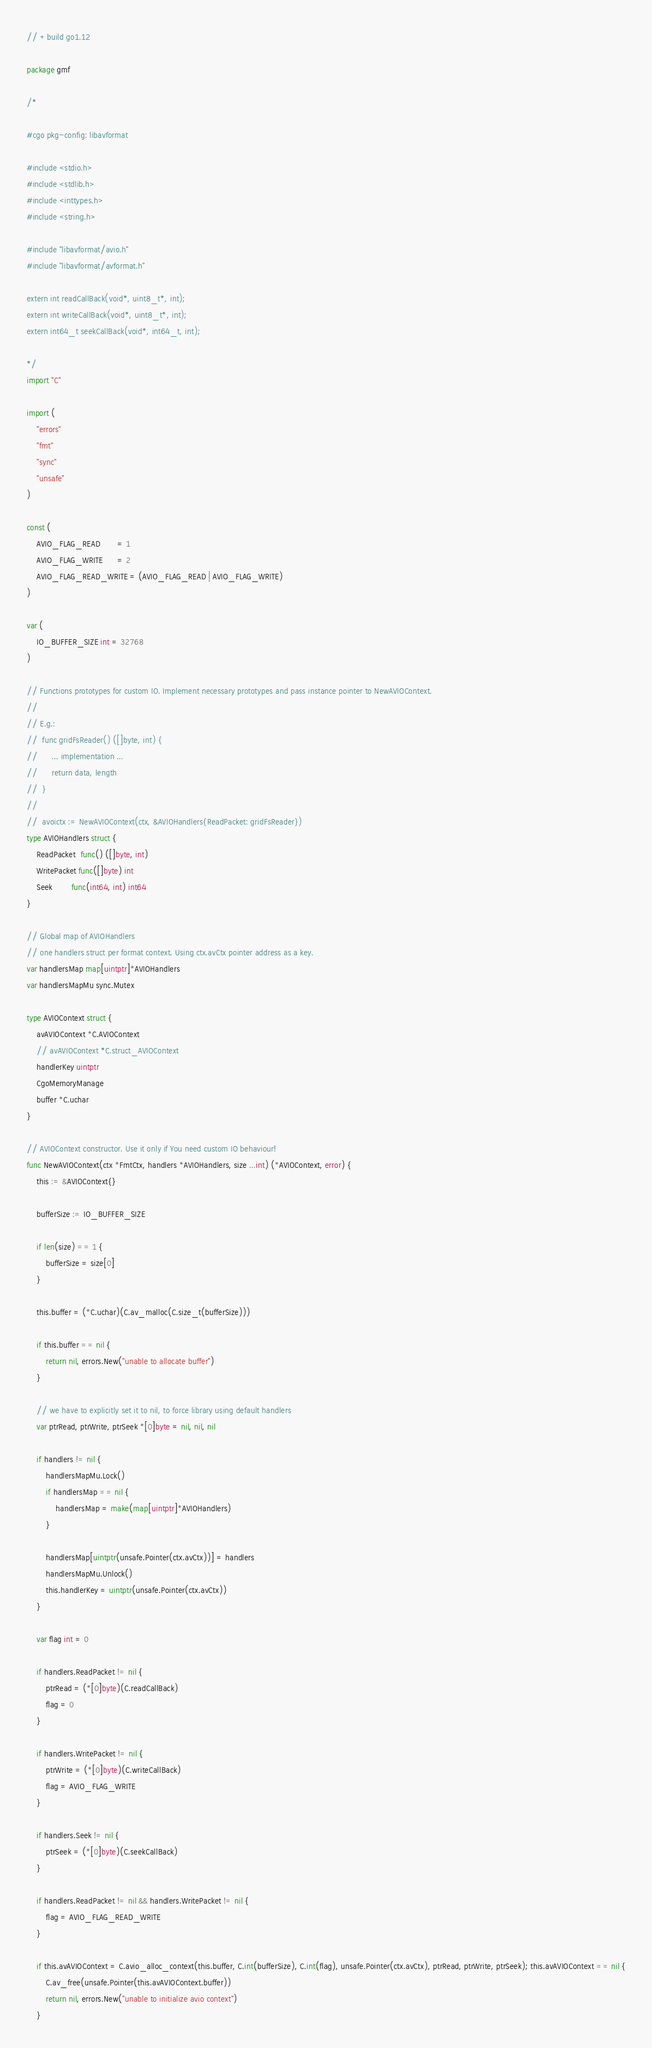<code> <loc_0><loc_0><loc_500><loc_500><_Go_>// +build go1.12

package gmf

/*

#cgo pkg-config: libavformat

#include <stdio.h>
#include <stdlib.h>
#include <inttypes.h>
#include <string.h>

#include "libavformat/avio.h"
#include "libavformat/avformat.h"

extern int readCallBack(void*, uint8_t*, int);
extern int writeCallBack(void*, uint8_t*, int);
extern int64_t seekCallBack(void*, int64_t, int);

*/
import "C"

import (
	"errors"
	"fmt"
	"sync"
	"unsafe"
)

const (
	AVIO_FLAG_READ       = 1
	AVIO_FLAG_WRITE      = 2
	AVIO_FLAG_READ_WRITE = (AVIO_FLAG_READ | AVIO_FLAG_WRITE)
)

var (
	IO_BUFFER_SIZE int = 32768
)

// Functions prototypes for custom IO. Implement necessary prototypes and pass instance pointer to NewAVIOContext.
//
// E.g.:
// 	func gridFsReader() ([]byte, int) {
// 		... implementation ...
//		return data, length
//	}
//
//	avoictx := NewAVIOContext(ctx, &AVIOHandlers{ReadPacket: gridFsReader})
type AVIOHandlers struct {
	ReadPacket  func() ([]byte, int)
	WritePacket func([]byte) int
	Seek        func(int64, int) int64
}

// Global map of AVIOHandlers
// one handlers struct per format context. Using ctx.avCtx pointer address as a key.
var handlersMap map[uintptr]*AVIOHandlers
var handlersMapMu sync.Mutex

type AVIOContext struct {
	avAVIOContext *C.AVIOContext
	// avAVIOContext *C.struct_AVIOContext
	handlerKey uintptr
	CgoMemoryManage
	buffer *C.uchar
}

// AVIOContext constructor. Use it only if You need custom IO behaviour!
func NewAVIOContext(ctx *FmtCtx, handlers *AVIOHandlers, size ...int) (*AVIOContext, error) {
	this := &AVIOContext{}

	bufferSize := IO_BUFFER_SIZE

	if len(size) == 1 {
		bufferSize = size[0]
	}

	this.buffer = (*C.uchar)(C.av_malloc(C.size_t(bufferSize)))

	if this.buffer == nil {
		return nil, errors.New("unable to allocate buffer")
	}

	// we have to explicitly set it to nil, to force library using default handlers
	var ptrRead, ptrWrite, ptrSeek *[0]byte = nil, nil, nil

	if handlers != nil {
		handlersMapMu.Lock()
		if handlersMap == nil {
			handlersMap = make(map[uintptr]*AVIOHandlers)
		}

		handlersMap[uintptr(unsafe.Pointer(ctx.avCtx))] = handlers
		handlersMapMu.Unlock()
		this.handlerKey = uintptr(unsafe.Pointer(ctx.avCtx))
	}

	var flag int = 0

	if handlers.ReadPacket != nil {
		ptrRead = (*[0]byte)(C.readCallBack)
		flag = 0
	}

	if handlers.WritePacket != nil {
		ptrWrite = (*[0]byte)(C.writeCallBack)
		flag = AVIO_FLAG_WRITE
	}

	if handlers.Seek != nil {
		ptrSeek = (*[0]byte)(C.seekCallBack)
	}

	if handlers.ReadPacket != nil && handlers.WritePacket != nil {
		flag = AVIO_FLAG_READ_WRITE
	}

	if this.avAVIOContext = C.avio_alloc_context(this.buffer, C.int(bufferSize), C.int(flag), unsafe.Pointer(ctx.avCtx), ptrRead, ptrWrite, ptrSeek); this.avAVIOContext == nil {
		C.av_free(unsafe.Pointer(this.avAVIOContext.buffer))
		return nil, errors.New("unable to initialize avio context")
	}
</code> 